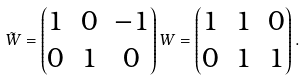Convert formula to latex. <formula><loc_0><loc_0><loc_500><loc_500>\tilde { W } = \begin{pmatrix} 1 & 0 & - 1 \\ 0 & 1 & 0 \end{pmatrix} W = \begin{pmatrix} 1 & 1 & 0 \\ 0 & 1 & 1 \end{pmatrix} .</formula> 